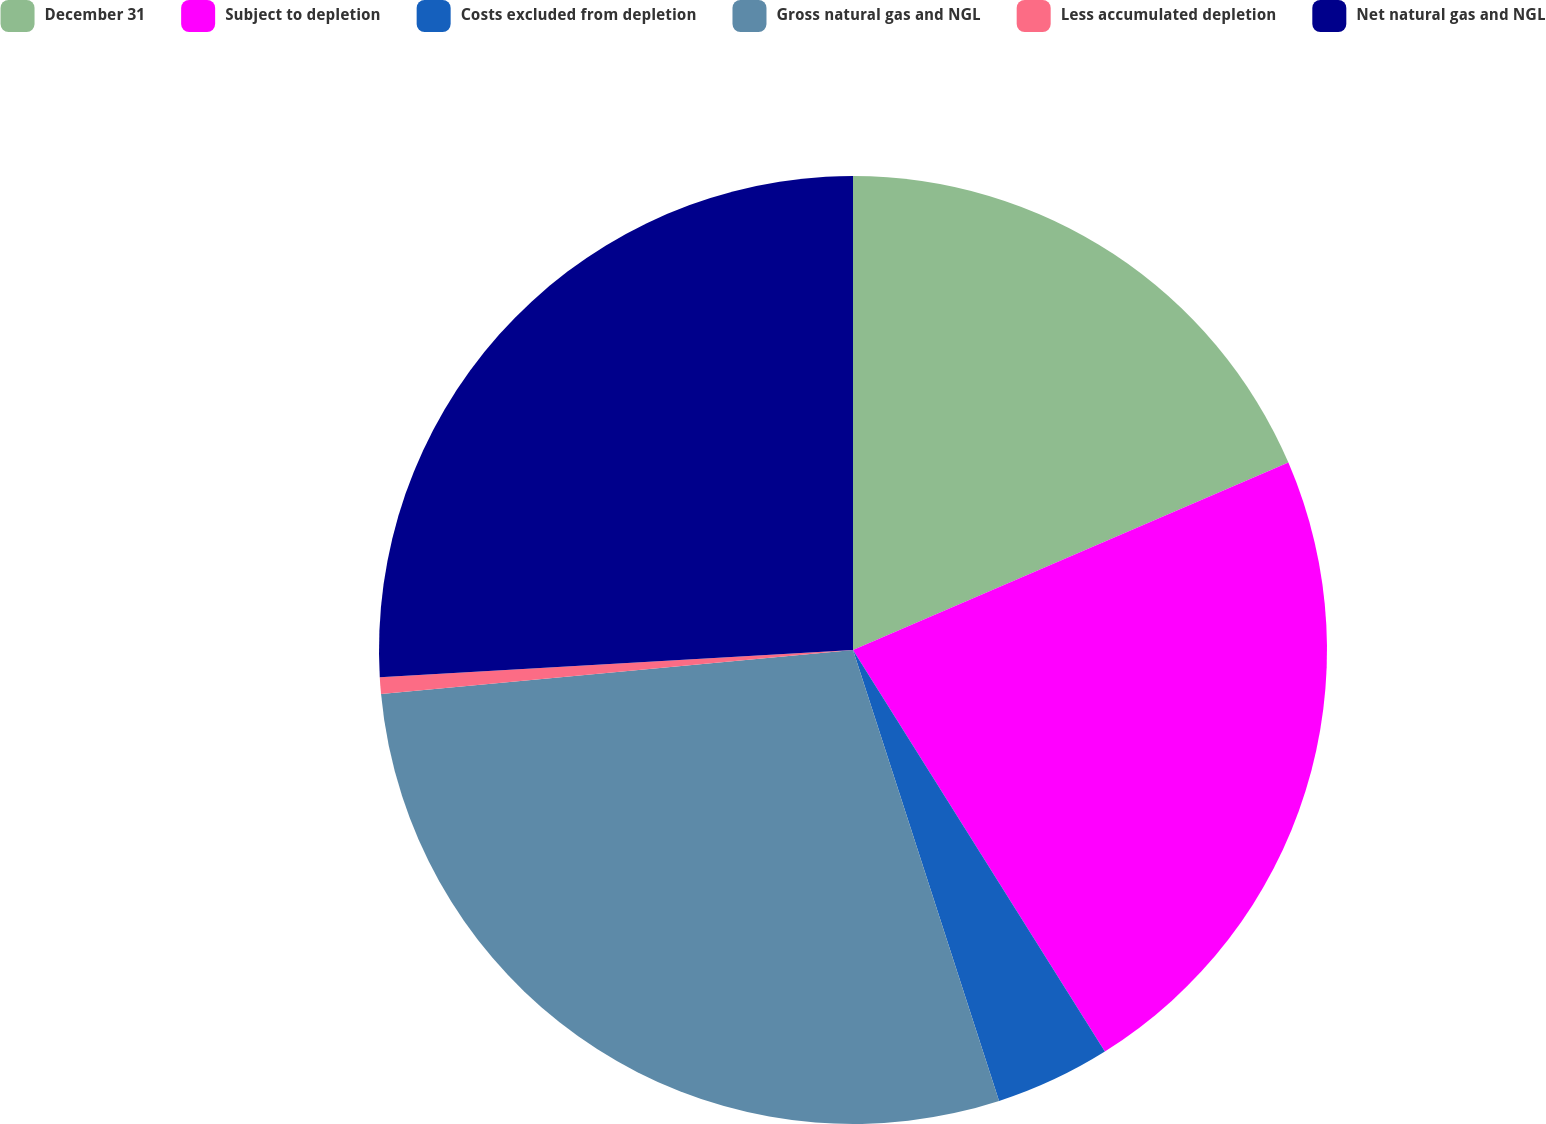<chart> <loc_0><loc_0><loc_500><loc_500><pie_chart><fcel>December 31<fcel>Subject to depletion<fcel>Costs excluded from depletion<fcel>Gross natural gas and NGL<fcel>Less accumulated depletion<fcel>Net natural gas and NGL<nl><fcel>18.53%<fcel>22.55%<fcel>3.93%<fcel>28.5%<fcel>0.57%<fcel>25.91%<nl></chart> 